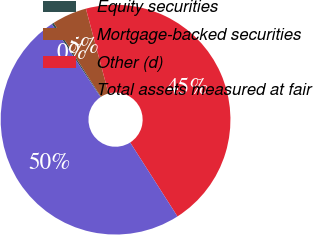Convert chart to OTSL. <chart><loc_0><loc_0><loc_500><loc_500><pie_chart><fcel>Equity securities<fcel>Mortgage-backed securities<fcel>Other (d)<fcel>Total assets measured at fair<nl><fcel>0.3%<fcel>4.9%<fcel>45.1%<fcel>49.7%<nl></chart> 